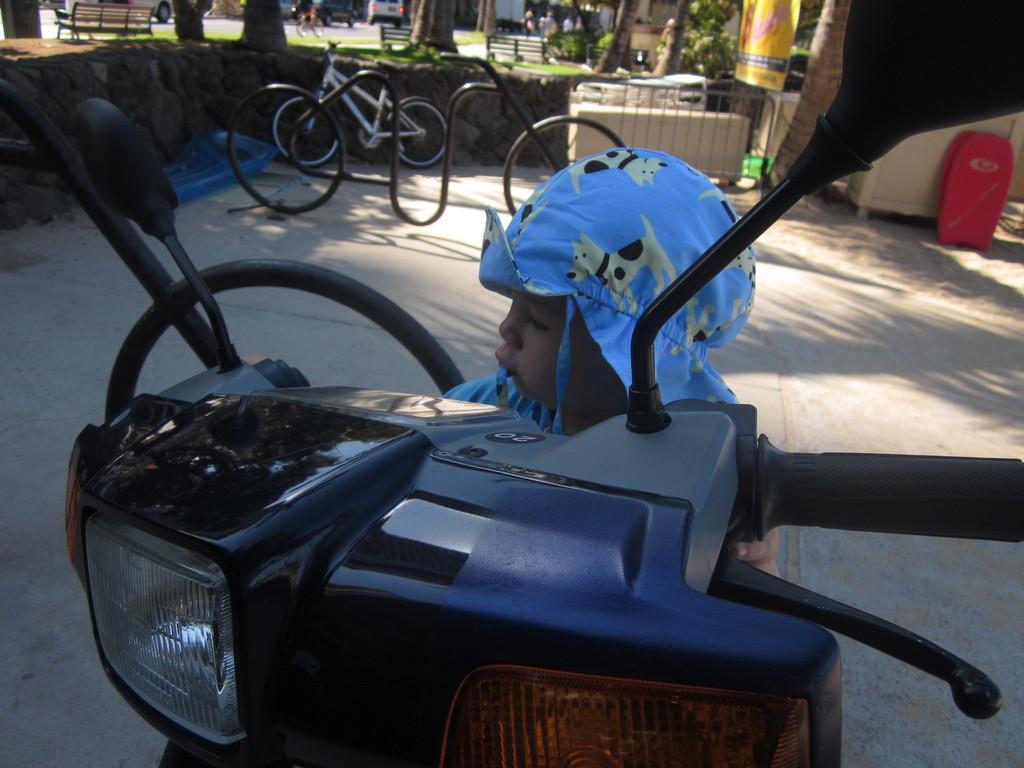In one or two sentences, can you explain what this image depicts? In the foreground of the image we can see a boy wearing a dress is standing on a motorcycle placed on the ground. In the background, we can see group of vehicles parked on the road, a bench is placed on the ground, a group of trees, metal railing and a trash bin. 